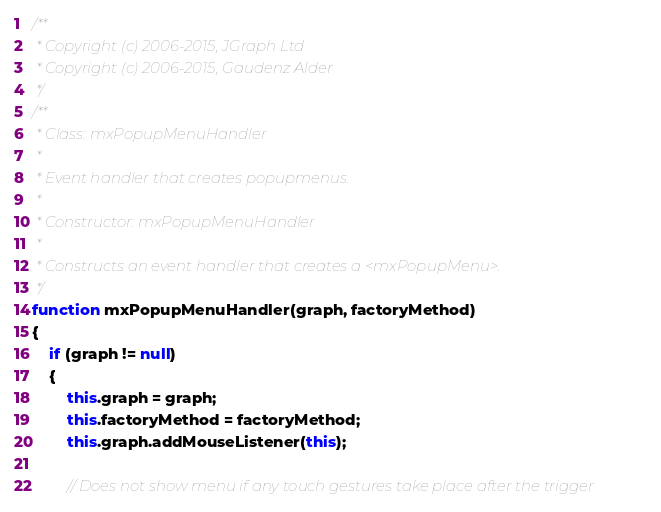Convert code to text. <code><loc_0><loc_0><loc_500><loc_500><_JavaScript_>/**
 * Copyright (c) 2006-2015, JGraph Ltd
 * Copyright (c) 2006-2015, Gaudenz Alder
 */
/**
 * Class: mxPopupMenuHandler
 *
 * Event handler that creates popupmenus.
 *
 * Constructor: mxPopupMenuHandler
 *
 * Constructs an event handler that creates a <mxPopupMenu>.
 */
function mxPopupMenuHandler(graph, factoryMethod)
{
	if (graph != null)
	{
		this.graph = graph;
		this.factoryMethod = factoryMethod;
		this.graph.addMouseListener(this);

		// Does not show menu if any touch gestures take place after the trigger</code> 